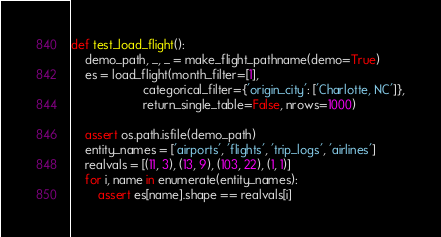<code> <loc_0><loc_0><loc_500><loc_500><_Python_>
def test_load_flight():
    demo_path, _, _ = make_flight_pathname(demo=True)
    es = load_flight(month_filter=[1],
                     categorical_filter={'origin_city': ['Charlotte, NC']},
                     return_single_table=False, nrows=1000)

    assert os.path.isfile(demo_path)
    entity_names = ['airports', 'flights', 'trip_logs', 'airlines']
    realvals = [(11, 3), (13, 9), (103, 22), (1, 1)]
    for i, name in enumerate(entity_names):
        assert es[name].shape == realvals[i]
</code> 